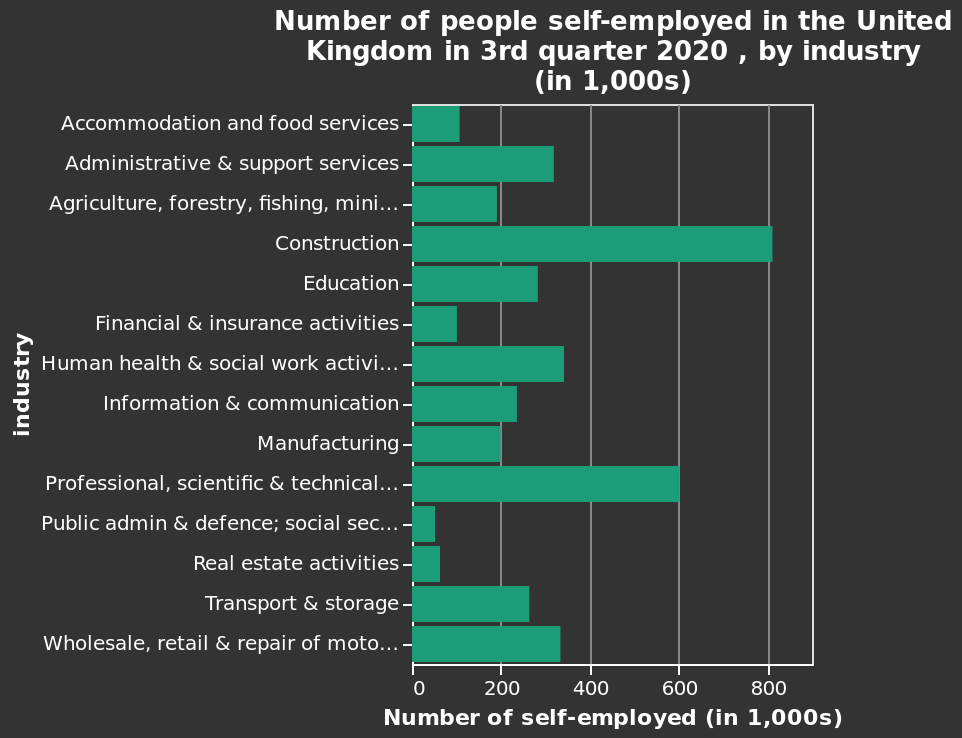<image>
Who are the most likely to be self-employed based on the chart? Construction workers are the most likely to be self-employed based on the chart. Which industry had the highest increase in the number of self-employed individuals compared to the previous quarter in the United Kingdom in 2020? The answer cannot be determined from the given information.  Are construction workers more likely to be self-employed compared to other professions according to the chart? Yes, according to the chart, construction workers are more likely to be self-employed compared to other professions. 